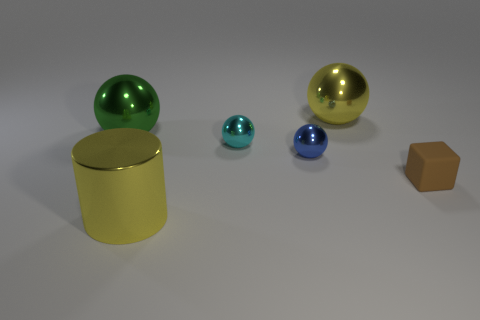Subtract all yellow spheres. How many spheres are left? 3 Add 3 brown things. How many objects exist? 9 Subtract all yellow spheres. How many spheres are left? 3 Subtract 0 purple blocks. How many objects are left? 6 Subtract all cylinders. How many objects are left? 5 Subtract all blue spheres. Subtract all brown cylinders. How many spheres are left? 3 Subtract all small red metal cylinders. Subtract all cyan shiny spheres. How many objects are left? 5 Add 4 large yellow metal cylinders. How many large yellow metal cylinders are left? 5 Add 5 purple shiny balls. How many purple shiny balls exist? 5 